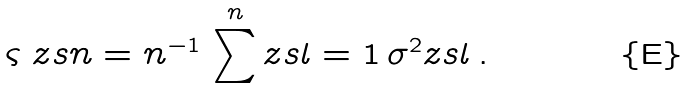<formula> <loc_0><loc_0><loc_500><loc_500>\varsigma _ { \ } z s { n } = n ^ { - 1 } \, \sum ^ { n } _ { \ } z s { l = 1 } \, \sigma ^ { 2 } _ { \ } z s { l } \, .</formula> 